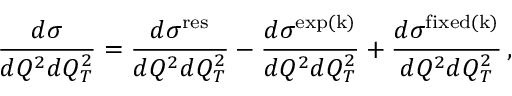<formula> <loc_0><loc_0><loc_500><loc_500>{ \frac { d \sigma } { d Q ^ { 2 } d Q _ { T } ^ { 2 } } } = { \frac { d \sigma ^ { r e s } } { d Q ^ { 2 } d Q _ { T } ^ { 2 } } } - { \frac { d \sigma ^ { e x p ( k ) } } { d Q ^ { 2 } d Q _ { T } ^ { 2 } } } + { \frac { d \sigma ^ { f i x e d ( k ) } } { d Q ^ { 2 } d Q _ { T } ^ { 2 } } } \, ,</formula> 